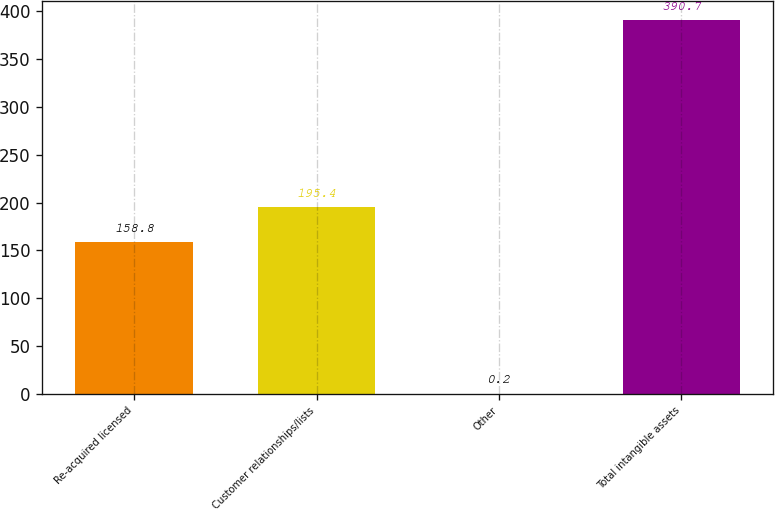Convert chart. <chart><loc_0><loc_0><loc_500><loc_500><bar_chart><fcel>Re-acquired licensed<fcel>Customer relationships/lists<fcel>Other<fcel>Total intangible assets<nl><fcel>158.8<fcel>195.4<fcel>0.2<fcel>390.7<nl></chart> 